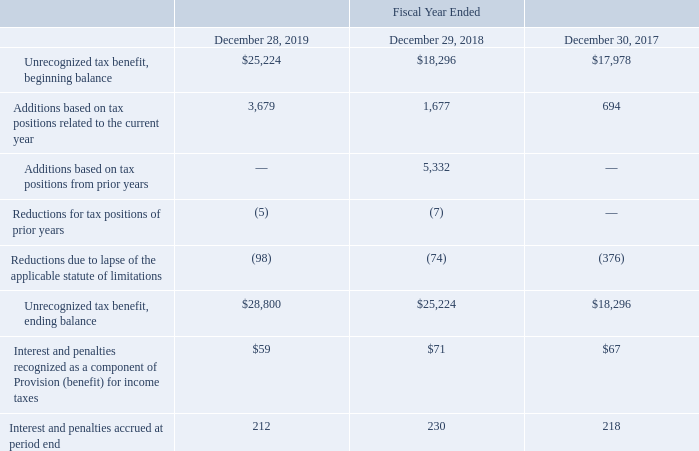Unrecognized Tax Benefits
We recognize the benefits of tax return positions if we determine that the positions are “more-likely-than-not” to be sustained by the taxing authority. Interest and penalties accrued on unrecognized tax benefits are recorded as tax expense in the period incurred. The following table reflects changes in the unrecognized tax benefits (in thousands):
Of the unrecognized tax benefits at December 28, 2019, $13.4 million would impact the effective tax rate if recognized.
The amount of income taxes we pay is subject to ongoing audits by federal, state and foreign tax authorities which might result in proposed assessments. Our estimate for the potential outcome for any uncertain tax issue is judgmental in nature. However, we believe we have adequately provided for any reasonably foreseeable outcome related to those matters.
Our future results may include favorable or unfavorable adjustments to our estimated tax liabilities in the period the assessments are made or resolved or when statutes of limitation on potential assessments expire. As of December 28, 2019, changes to our uncertain tax positions in the next 12 months that are reasonably possible are not expected to have a significant impact on our financial position or results of operations.
At December 28, 2019, our tax years 2016 through 2019, 2015 through 2019 and 2014 through 2019, remain open for examination in the federal, state and foreign jurisdictions, respectively. However, to the extent allowed by law, the taxing authorities may have the right to examine prior periods where net operating losses and credits were generated and carried forward, and make adjustments up to the net operating loss and credit carryforward amounts.
What is the unrecognized tax benefit, ending balance in 2019?
Answer scale should be: thousand. $28,800. What were the Unrecognized tax benefit, beginning balance in 2019, 2018 and 2017 respectively?
Answer scale should be: thousand. 25,224, 18,296, 17,978. Which tax years are open for examination in the federal, state and foreign jurisdictions respectively? 2016 through 2019, 2015 through 2019, 2014 through 2019. What is the change in the Unrecognized tax benefit, beginning balance from 2018 to 2019?
Answer scale should be: thousand. 25,224 - 18,296
Answer: 6928. What is the average Additions based on tax positions related to the current year from 2017-2019?
Answer scale should be: thousand. (3,679 + 1,677 + 694) / 3
Answer: 2016.67. Which year has the highest Unrecognized tax benefit, ending balance? 28,800> 25,224> 18,296
Answer: 2019. 